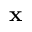<formula> <loc_0><loc_0><loc_500><loc_500>x</formula> 